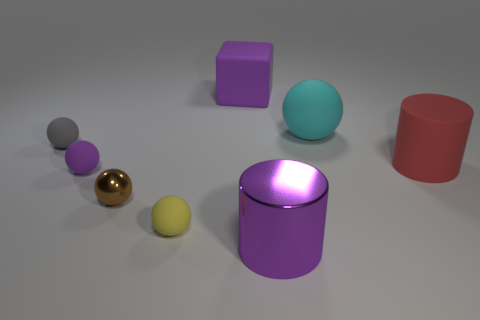There is a shiny object that is to the left of the cylinder on the left side of the large cyan matte ball; is there a object that is behind it?
Ensure brevity in your answer.  Yes. What number of tiny objects are either yellow matte objects or yellow rubber cylinders?
Your answer should be very brief. 1. There is a matte cylinder that is the same size as the purple metal thing; what is its color?
Make the answer very short. Red. There is a purple metal thing; what number of rubber things are left of it?
Ensure brevity in your answer.  4. Is there a big purple block that has the same material as the big red cylinder?
Your answer should be very brief. Yes. There is a big metal object that is the same color as the rubber block; what is its shape?
Keep it short and to the point. Cylinder. The cylinder in front of the tiny metallic sphere is what color?
Your response must be concise. Purple. Are there the same number of tiny purple rubber spheres that are right of the big red cylinder and yellow rubber spheres on the right side of the cyan rubber thing?
Offer a very short reply. Yes. What is the material of the big object in front of the small yellow matte sphere that is behind the big metallic object?
Give a very brief answer. Metal. What number of objects are either big purple blocks or tiny objects to the right of the tiny gray sphere?
Provide a succinct answer. 4. 